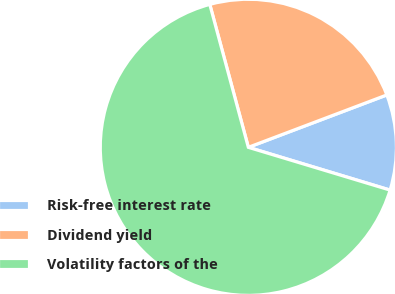Convert chart. <chart><loc_0><loc_0><loc_500><loc_500><pie_chart><fcel>Risk-free interest rate<fcel>Dividend yield<fcel>Volatility factors of the<nl><fcel>10.42%<fcel>23.44%<fcel>66.15%<nl></chart> 